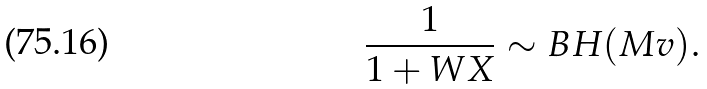Convert formula to latex. <formula><loc_0><loc_0><loc_500><loc_500>\frac { 1 } { 1 + W X } \sim B H ( M v ) .</formula> 